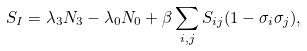Convert formula to latex. <formula><loc_0><loc_0><loc_500><loc_500>S _ { I } = \lambda _ { 3 } N _ { 3 } - \lambda _ { 0 } N _ { 0 } + \beta \sum _ { i , j } S _ { i j } ( 1 - \sigma _ { i } \sigma _ { j } ) ,</formula> 